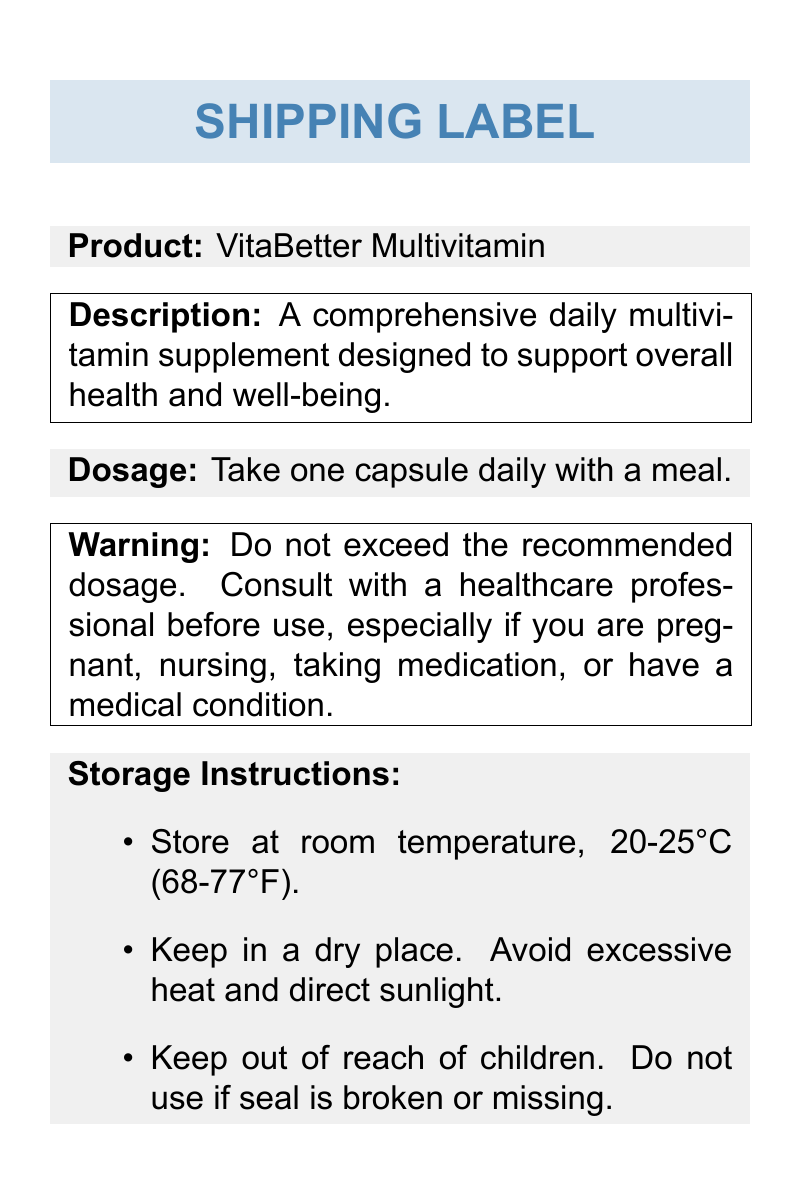what is the product name? The product name is mentioned in the document as "VitaBetter Multivitamin."
Answer: VitaBetter Multivitamin what is the recommended dosage? The recommended dosage is stated in the document as taking one capsule daily with a meal.
Answer: one capsule daily with a meal what should you do if the seal is broken? The document states that you should not use the product if the seal is broken or missing.
Answer: do not use how much Vitamin C is in one serving? The document provides the amount of Vitamin C in the key ingredients section, which is 90 mg.
Answer: 90 mg what temperature range should the supplement be stored at? The storage instructions indicate that the product should be stored at room temperature, which is 20-25°C (68-77°F).
Answer: 20-25°C (68-77°F) what is the warning associated with the product? The warning advises not to exceed the recommended dosage and suggests consulting with a healthcare professional before use.
Answer: Do not exceed the recommended dosage how many key ingredients are listed? The document lists six key ingredients in the ingredient section.
Answer: six what is one of the storage instructions mentioned? One storage instruction is to keep the supplement in a dry place to avoid excessive heat and direct sunlight.
Answer: Keep in a dry place what is the product description? The description section provides a summary of the product's purpose, stating it is designed to support overall health and well-being.
Answer: A comprehensive daily multivitamin supplement designed to support overall health and well-being 